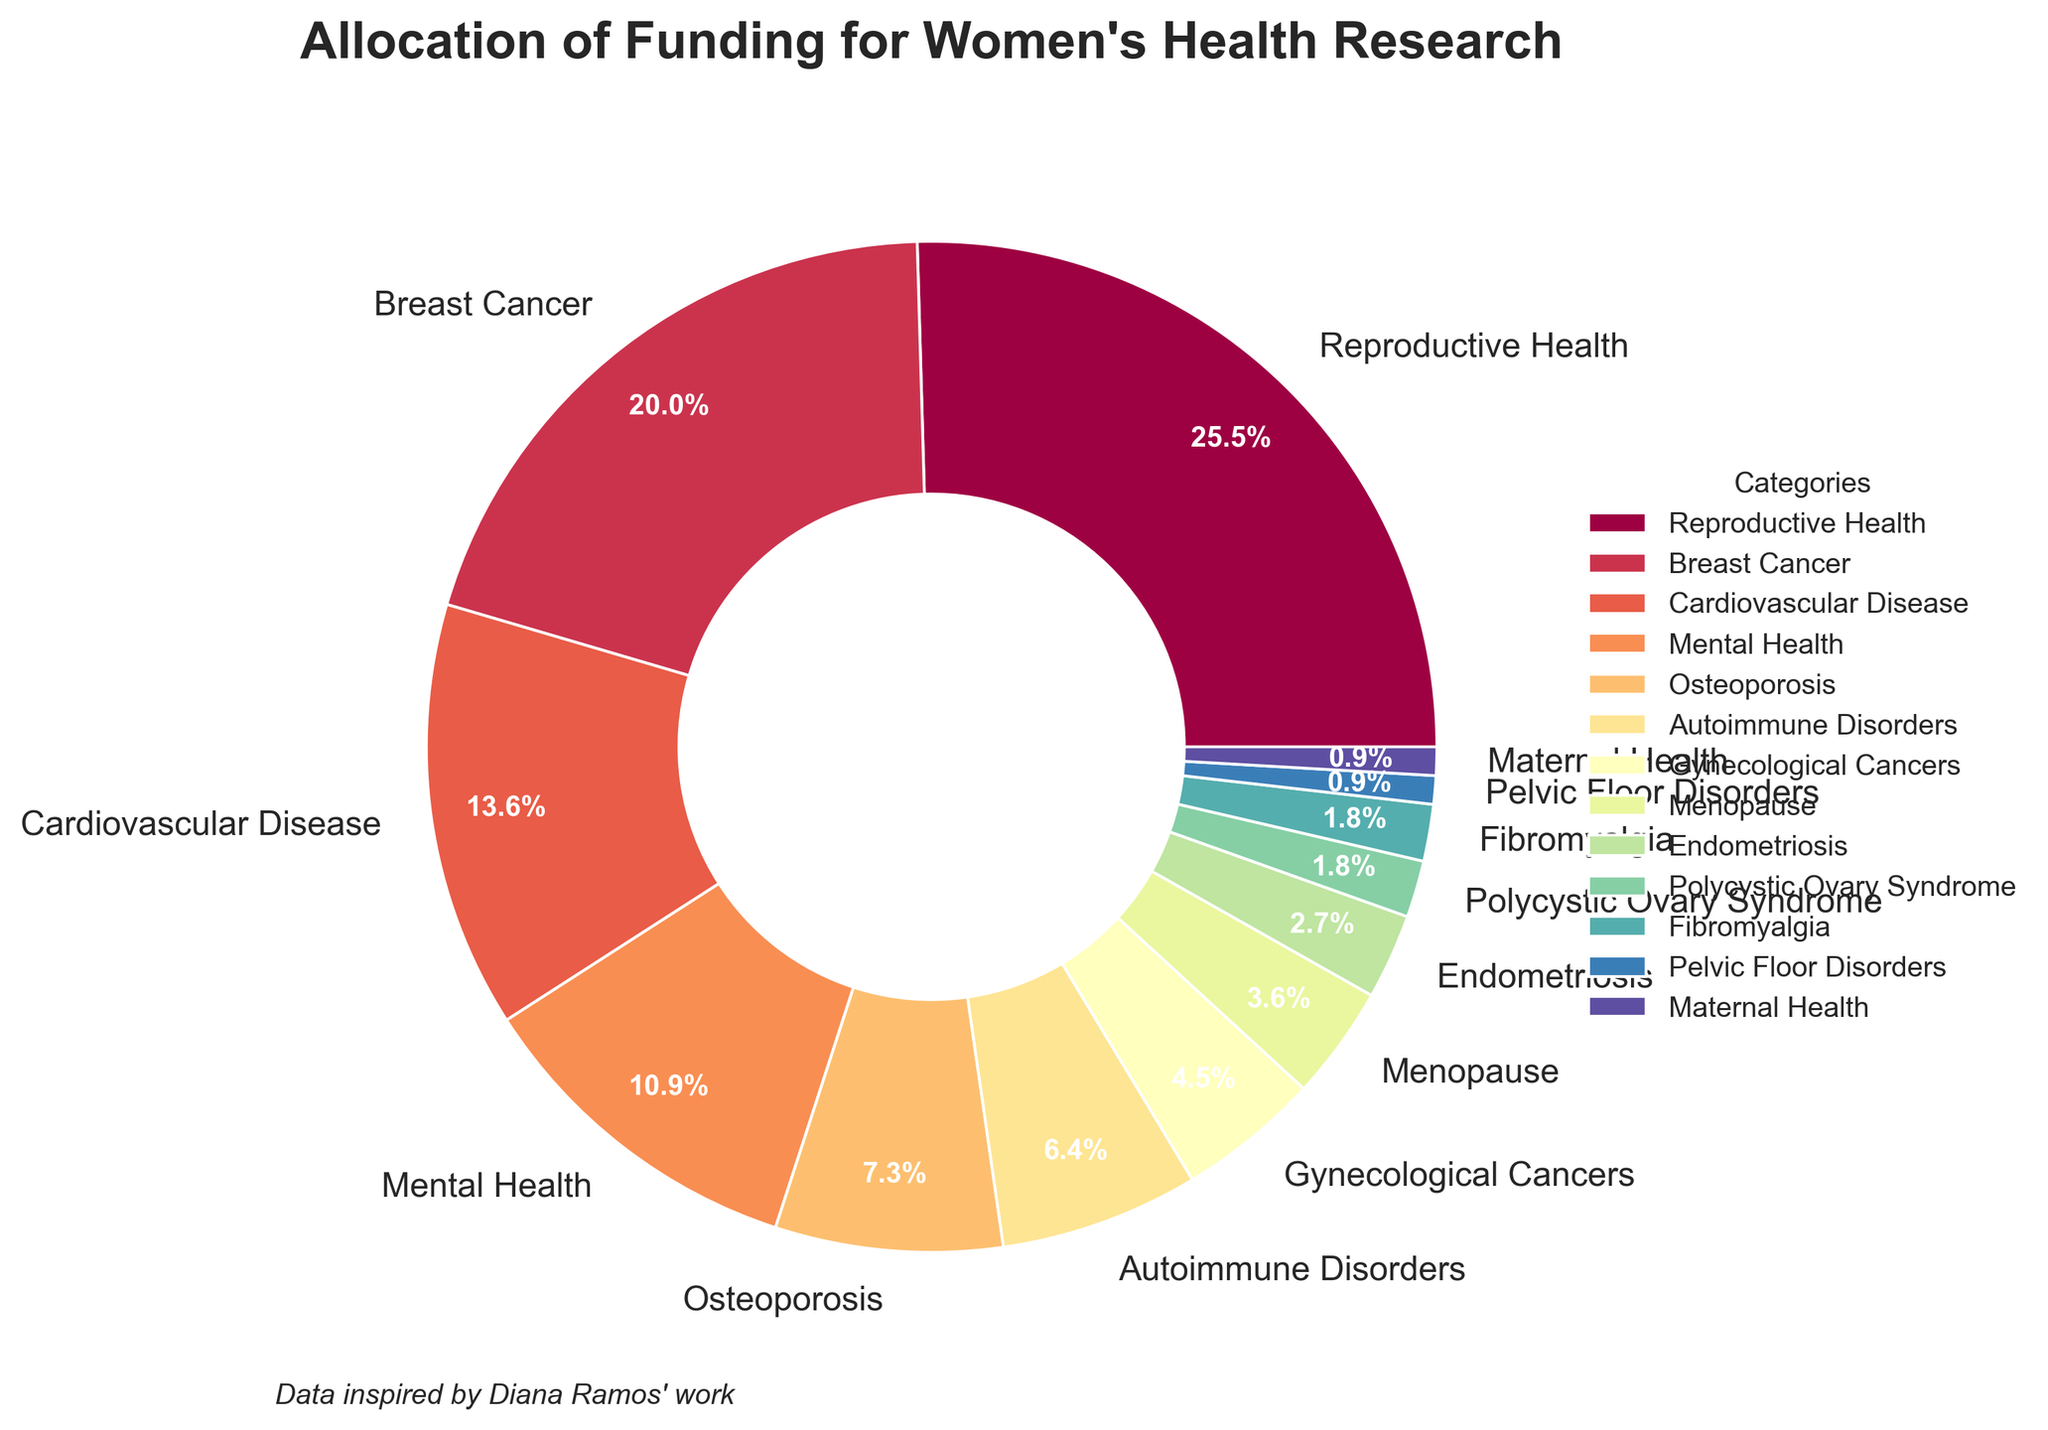Which category receives the highest percentage of funding? The pie chart shows that the "Reproductive Health" category has the largest wedge and the percentage label is 28%.
Answer: Reproductive Health What is the combined percentage of funding for Breast Cancer and Cardiovascular Disease? Summing the percentages for "Breast Cancer" (22%) and "Cardiovascular Disease" (15%) gives 22 + 15 = 37%.
Answer: 37% How does the funding for Osteoporosis compare to that for Autoimmune Disorders? The pie chart shows that "Osteoporosis" has 8% funding while "Autoimmune Disorders" has 7% funding, thus Osteoporosis has 1% more funding.
Answer: Osteoporosis has 1% more funding Which category receives the least funding and what is its percentage? The smallest wedge in the pie chart is labeled "Maternal Health," which has a percentage of 1%.
Answer: Maternal Health, 1% Is the funding for Mental Health greater than the combined funding for Endometriosis, Polycystic Ovary Syndrome, and Fibromyalgia? The percentages for "Endometriosis," "Polycystic Ovary Syndrome," and "Fibromyalgia" are 3%, 2%, and 2% respectively, which sum to 3 + 2 + 2 = 7%. "Mental Health" has 12%, which is greater than 7%.
Answer: Yes, Mental Health's 12% is greater What percentage of the total funding is allocated to both Breast Cancer and Gynecological Cancers? Adding the percentages for "Breast Cancer" (22%) and "Gynecological Cancers" (5%) gives 22 + 5 = 27%.
Answer: 27% Which categories collectively account for a third of the total funding? "Reproductive Health" has 28% and "Pelvic Floor Disorders," "Maternal Health," and "Fibromyalgia" have 1%, 1%, and 2% respectively. Adding 28% + 1% + 1% + 2% = 32%. These round up to roughly a third of the total funding.
Answer: Reproductive Health, Pelvic Floor Disorders, Maternal Health, Fibromyalgia If the funding for Mental Health were doubled, what would be its new percentage, and would it surpass the current percentage for Breast Cancer? Doubling the 12% allocation for "Mental Health" gives 12 * 2 = 24%, which is greater than "Breast Cancer’s" 22%.
Answer: Yes, 24% would surpass 22% What visual clues indicate the difference in funding between Reproductive Health and Menopause? The wedge for "Reproductive Health" is significantly larger and occupies more space in the pie chart compared to the relatively smaller wedge for "Menopause," and their labels indicate 28% and 4% respectively.
Answer: Reproductive Health wedge is larger, 28% vs 4% What is the total percentage of funding for categories that receive less than 5% each? The categories "Menopause," "Endometriosis," "Polycystic Ovary Syndrome," "Fibromyalgia," "Pelvic Floor Disorders," and "Maternal Health" have percentages 4%, 3%, 2%, 2%, 1%, and 1% respectively. Summing them gives 4 + 3 + 2 + 2 + 1 + 1 = 13%.
Answer: 13% 